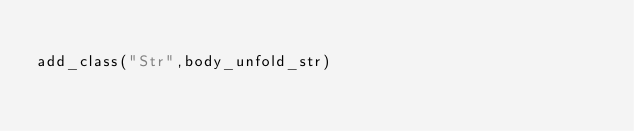Convert code to text. <code><loc_0><loc_0><loc_500><loc_500><_Python_>
add_class("Str",body_unfold_str)

</code> 